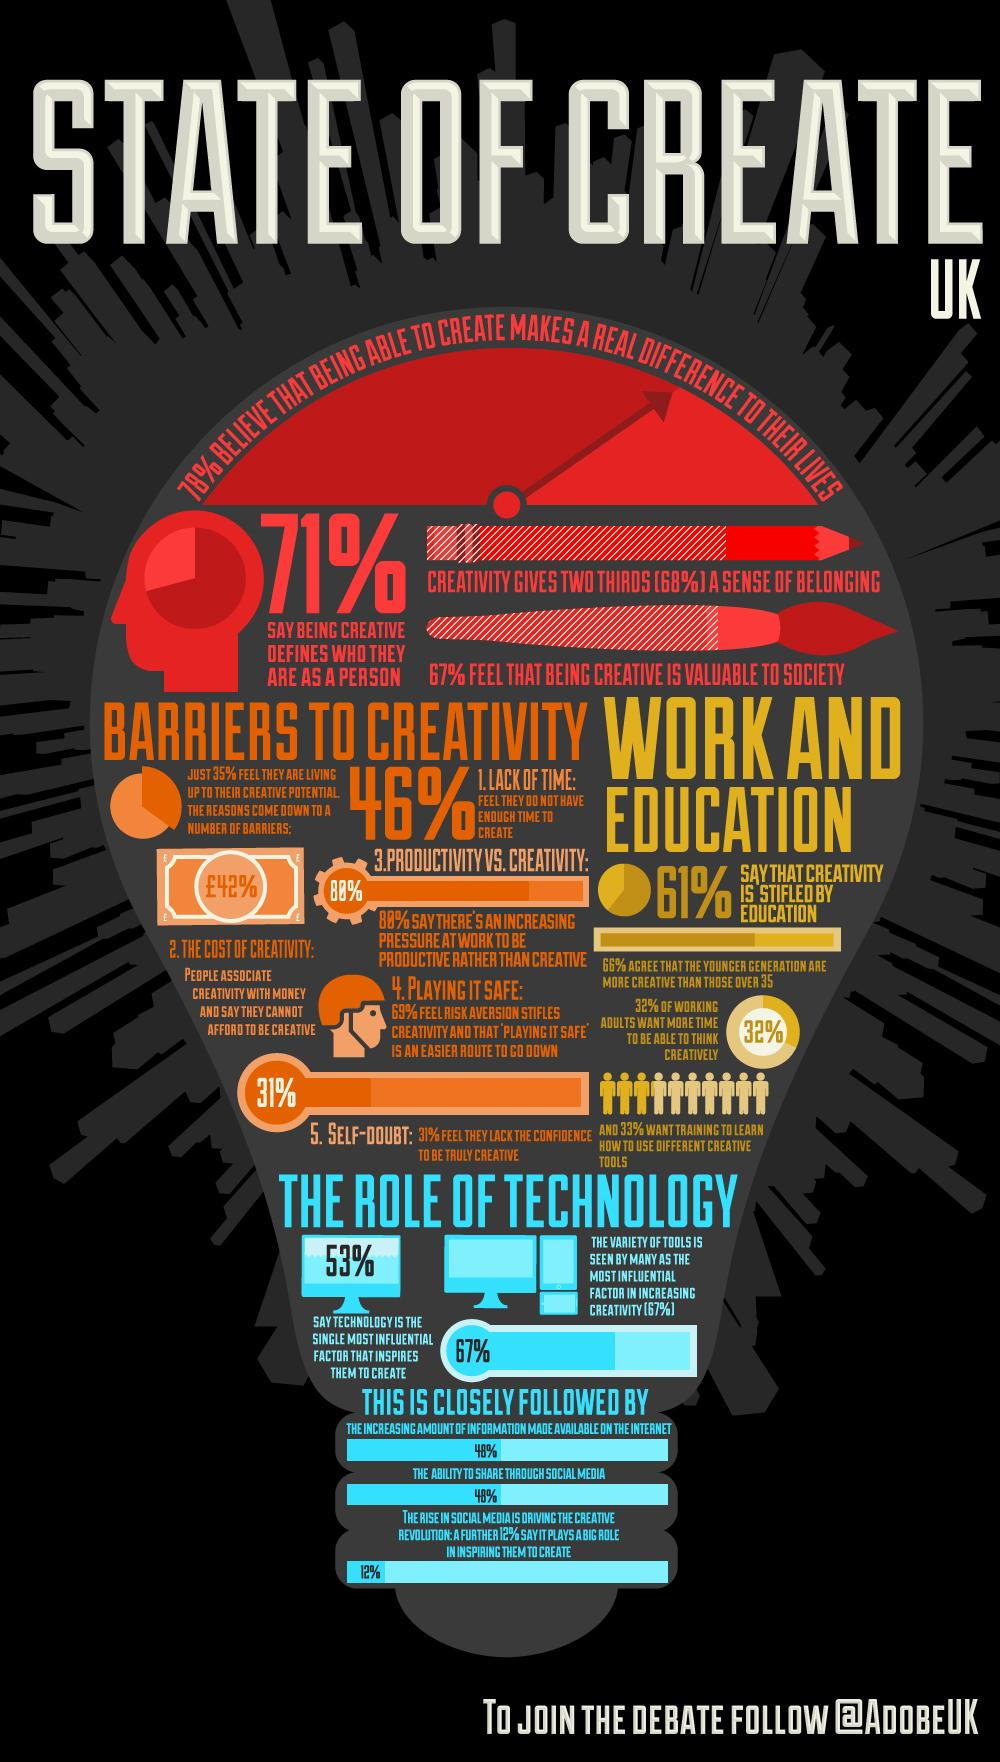Point out several critical features in this image. A recent survey in the United Kingdom found that 46% of people do not have enough time to be creative. According to a survey in the UK, 39% of people do not believe that education stifles creativity. According to a recent survey in the UK, 69% of people are not in self-doubt as far as their creativity is concerned. According to a recent survey, an overwhelming 78% of UK residents believe that being creative has a significant impact on their lives. 